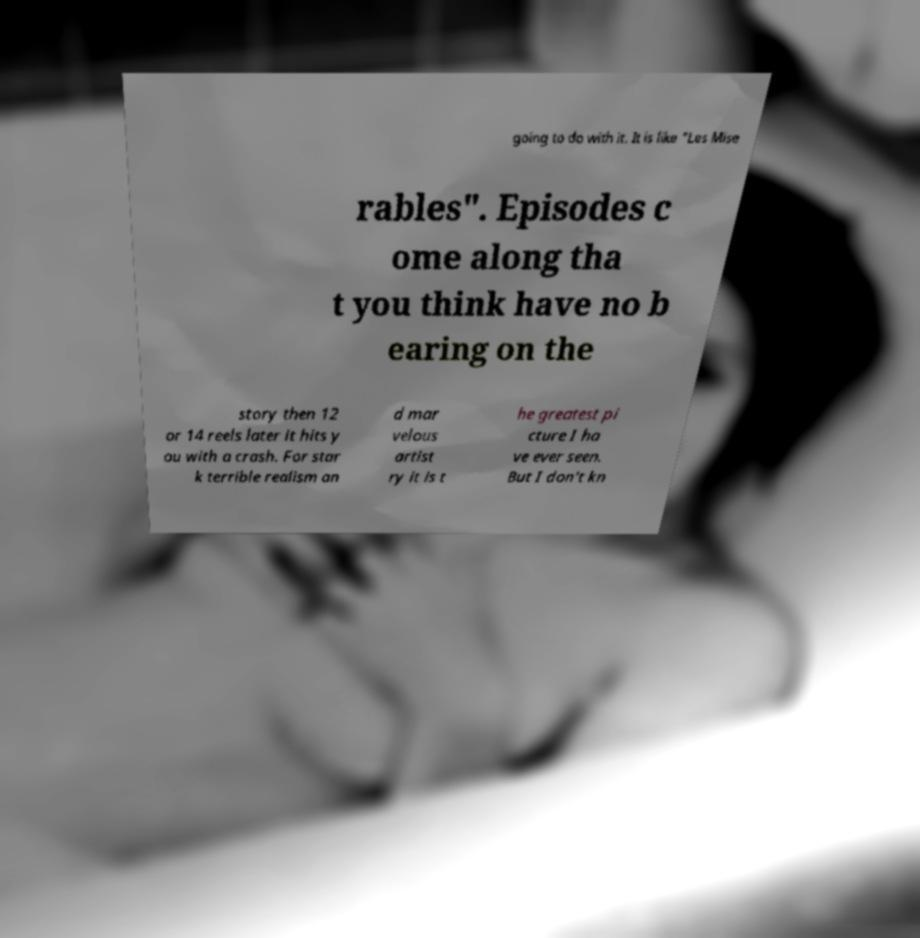Please read and relay the text visible in this image. What does it say? going to do with it. It is like "Les Mise rables". Episodes c ome along tha t you think have no b earing on the story then 12 or 14 reels later it hits y ou with a crash. For star k terrible realism an d mar velous artist ry it is t he greatest pi cture I ha ve ever seen. But I don't kn 